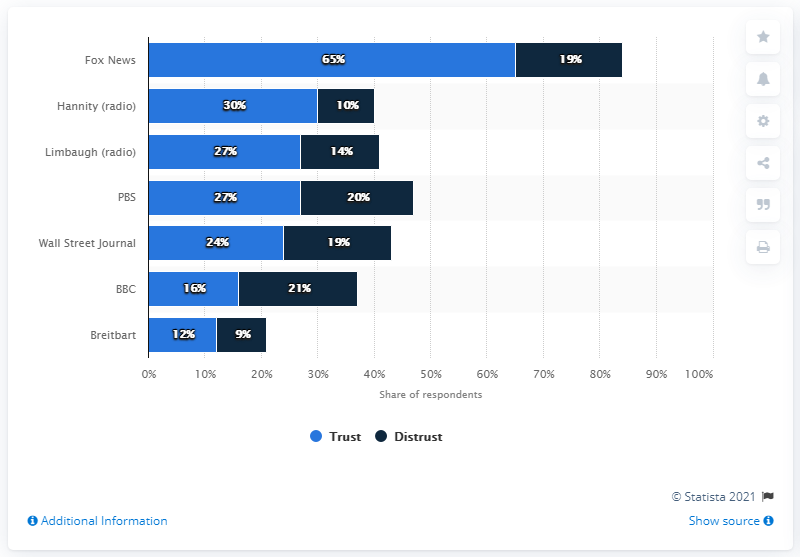Highlight a few significant elements in this photo. According to a survey conducted in November 2019, the highest trusted political news sources in the United States are 65%. Fox News was the most widely trusted political news source among Republicans, according to a study. The difference between the shortest light blue bar and the tallest dark blue bar is 9. 